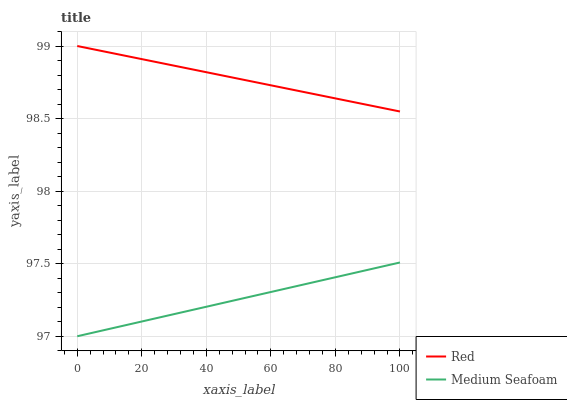Does Medium Seafoam have the minimum area under the curve?
Answer yes or no. Yes. Does Red have the maximum area under the curve?
Answer yes or no. Yes. Does Red have the minimum area under the curve?
Answer yes or no. No. Is Red the smoothest?
Answer yes or no. Yes. Is Medium Seafoam the roughest?
Answer yes or no. Yes. Is Red the roughest?
Answer yes or no. No. Does Medium Seafoam have the lowest value?
Answer yes or no. Yes. Does Red have the lowest value?
Answer yes or no. No. Does Red have the highest value?
Answer yes or no. Yes. Is Medium Seafoam less than Red?
Answer yes or no. Yes. Is Red greater than Medium Seafoam?
Answer yes or no. Yes. Does Medium Seafoam intersect Red?
Answer yes or no. No. 